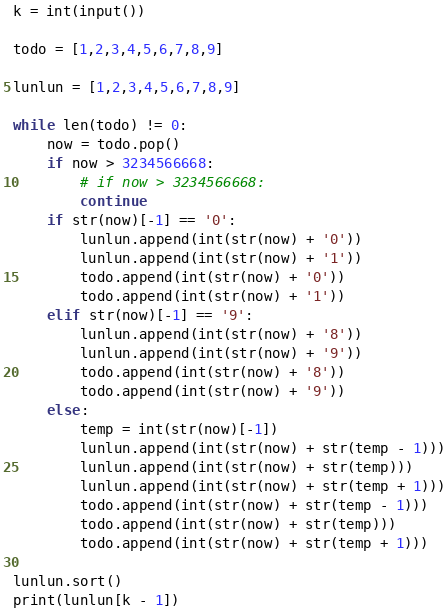Convert code to text. <code><loc_0><loc_0><loc_500><loc_500><_Python_>k = int(input())

todo = [1,2,3,4,5,6,7,8,9]

lunlun = [1,2,3,4,5,6,7,8,9]

while len(todo) != 0:
    now = todo.pop()
    if now > 3234566668:
        # if now > 3234566668:
        continue
    if str(now)[-1] == '0':
        lunlun.append(int(str(now) + '0'))
        lunlun.append(int(str(now) + '1'))
        todo.append(int(str(now) + '0'))
        todo.append(int(str(now) + '1'))
    elif str(now)[-1] == '9':
        lunlun.append(int(str(now) + '8'))
        lunlun.append(int(str(now) + '9'))
        todo.append(int(str(now) + '8'))
        todo.append(int(str(now) + '9'))
    else:
        temp = int(str(now)[-1])
        lunlun.append(int(str(now) + str(temp - 1)))
        lunlun.append(int(str(now) + str(temp)))
        lunlun.append(int(str(now) + str(temp + 1)))
        todo.append(int(str(now) + str(temp - 1)))
        todo.append(int(str(now) + str(temp)))
        todo.append(int(str(now) + str(temp + 1)))

lunlun.sort()
print(lunlun[k - 1])

</code> 